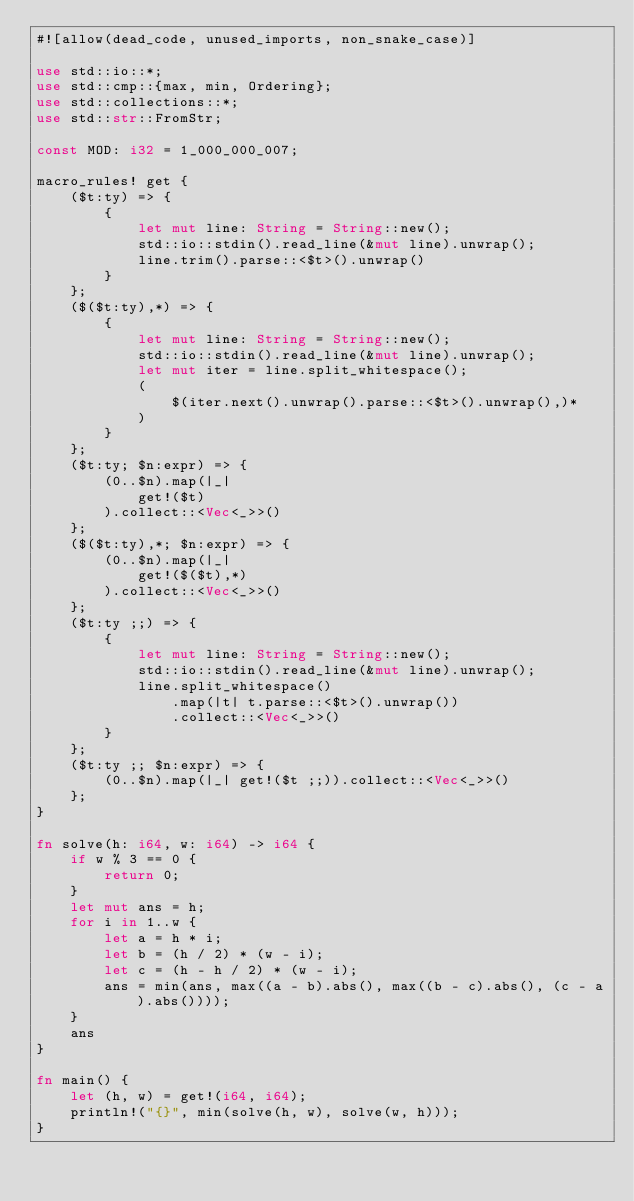Convert code to text. <code><loc_0><loc_0><loc_500><loc_500><_Rust_>#![allow(dead_code, unused_imports, non_snake_case)]

use std::io::*;
use std::cmp::{max, min, Ordering};
use std::collections::*;
use std::str::FromStr;

const MOD: i32 = 1_000_000_007;

macro_rules! get {
    ($t:ty) => {
        {
            let mut line: String = String::new();
            std::io::stdin().read_line(&mut line).unwrap();
            line.trim().parse::<$t>().unwrap()
        }
    };
    ($($t:ty),*) => {
        {
            let mut line: String = String::new();
            std::io::stdin().read_line(&mut line).unwrap();
            let mut iter = line.split_whitespace();
            (
                $(iter.next().unwrap().parse::<$t>().unwrap(),)*
            )
        }
    };
    ($t:ty; $n:expr) => {
        (0..$n).map(|_|
            get!($t)
        ).collect::<Vec<_>>()
    };
    ($($t:ty),*; $n:expr) => {
        (0..$n).map(|_|
            get!($($t),*)
        ).collect::<Vec<_>>()
    };
    ($t:ty ;;) => {
        {
            let mut line: String = String::new();
            std::io::stdin().read_line(&mut line).unwrap();
            line.split_whitespace()
                .map(|t| t.parse::<$t>().unwrap())
                .collect::<Vec<_>>()
        }
    };
    ($t:ty ;; $n:expr) => {
        (0..$n).map(|_| get!($t ;;)).collect::<Vec<_>>()
    };
}

fn solve(h: i64, w: i64) -> i64 {
    if w % 3 == 0 {
        return 0;
    }
    let mut ans = h;
    for i in 1..w {
        let a = h * i;
        let b = (h / 2) * (w - i);
        let c = (h - h / 2) * (w - i);
        ans = min(ans, max((a - b).abs(), max((b - c).abs(), (c - a).abs())));
    }
    ans
}

fn main() {
    let (h, w) = get!(i64, i64);
    println!("{}", min(solve(h, w), solve(w, h)));
}</code> 